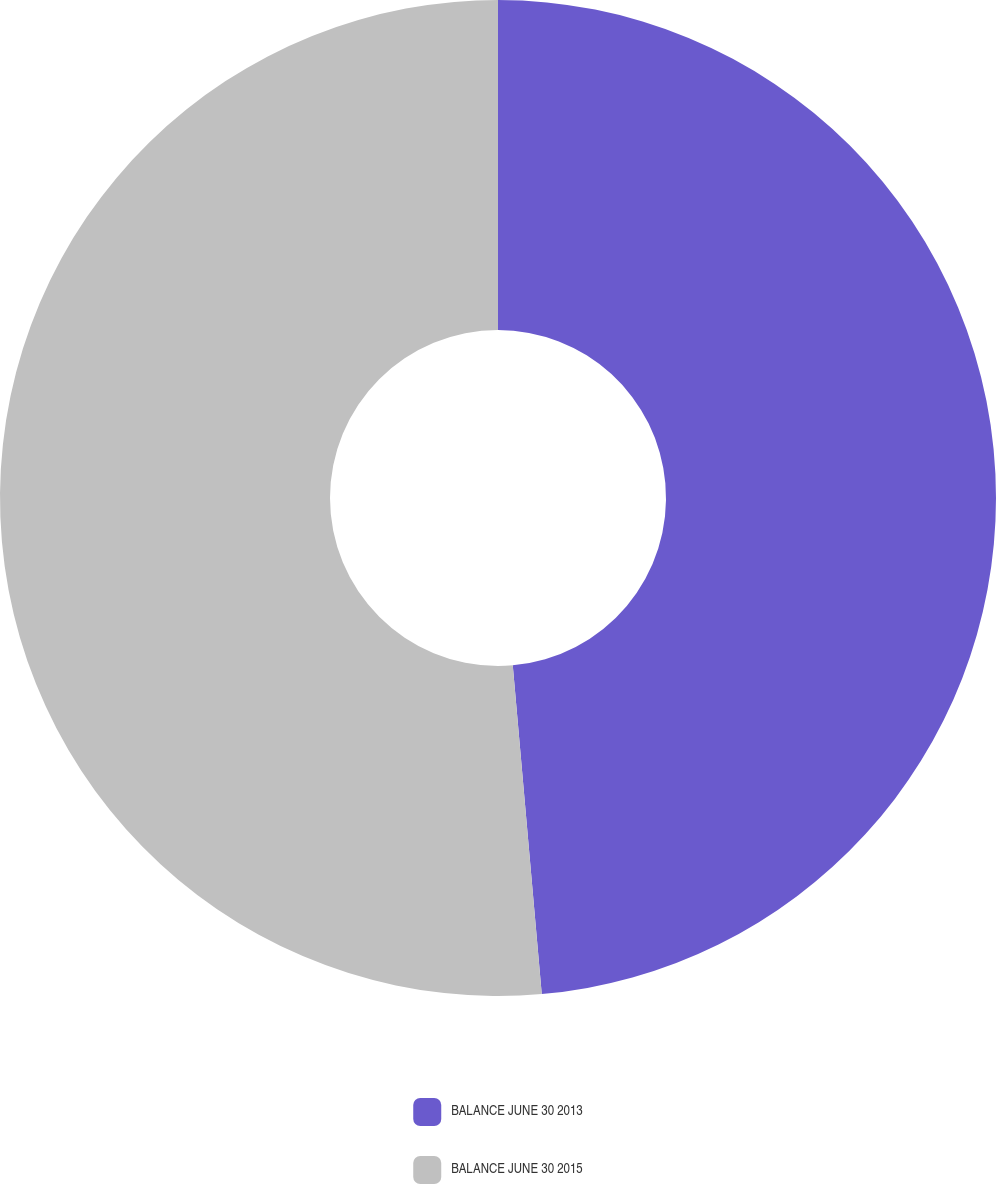Convert chart to OTSL. <chart><loc_0><loc_0><loc_500><loc_500><pie_chart><fcel>BALANCE JUNE 30 2013<fcel>BALANCE JUNE 30 2015<nl><fcel>48.6%<fcel>51.4%<nl></chart> 